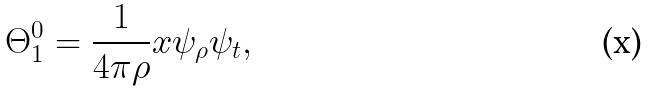<formula> <loc_0><loc_0><loc_500><loc_500>\Theta _ { 1 } ^ { 0 } = \frac { 1 } { 4 \pi \rho } x \psi _ { \rho } \psi _ { t } ,</formula> 